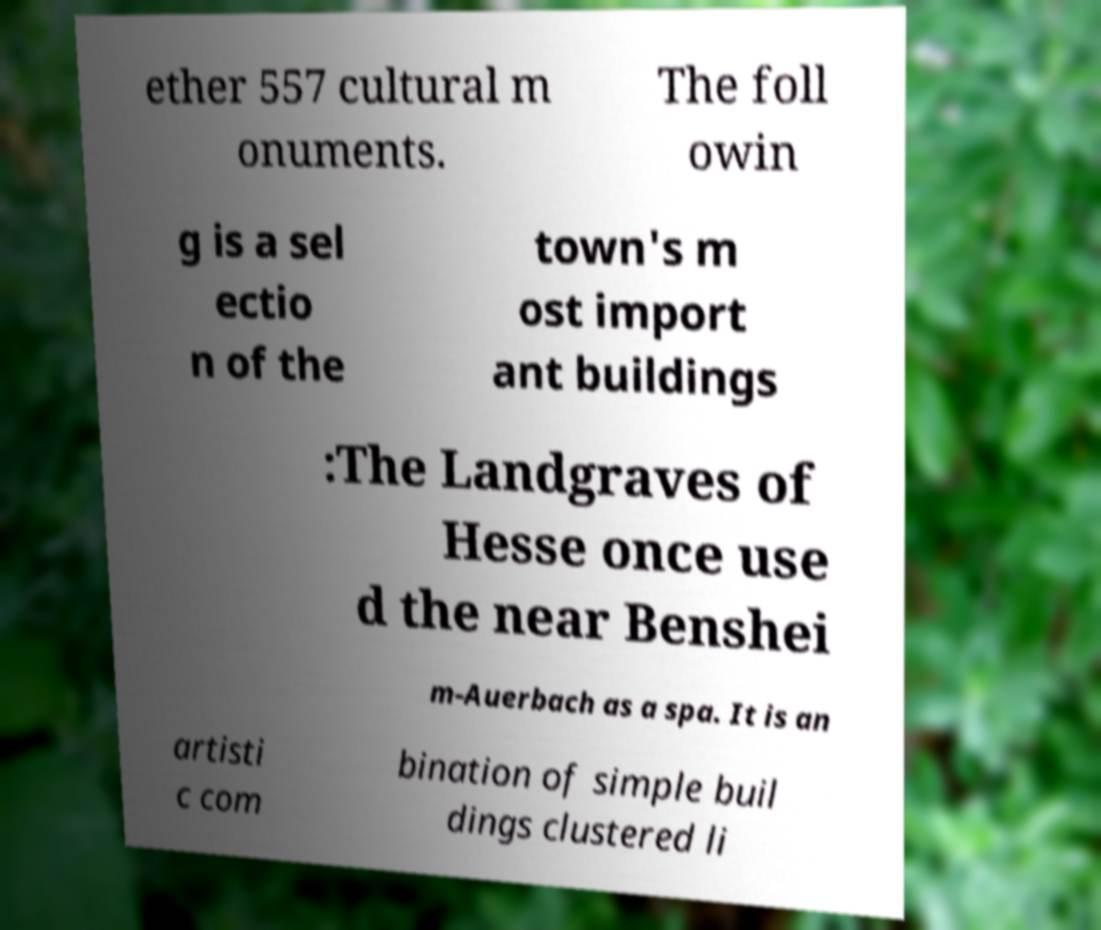There's text embedded in this image that I need extracted. Can you transcribe it verbatim? ether 557 cultural m onuments. The foll owin g is a sel ectio n of the town's m ost import ant buildings :The Landgraves of Hesse once use d the near Benshei m-Auerbach as a spa. It is an artisti c com bination of simple buil dings clustered li 